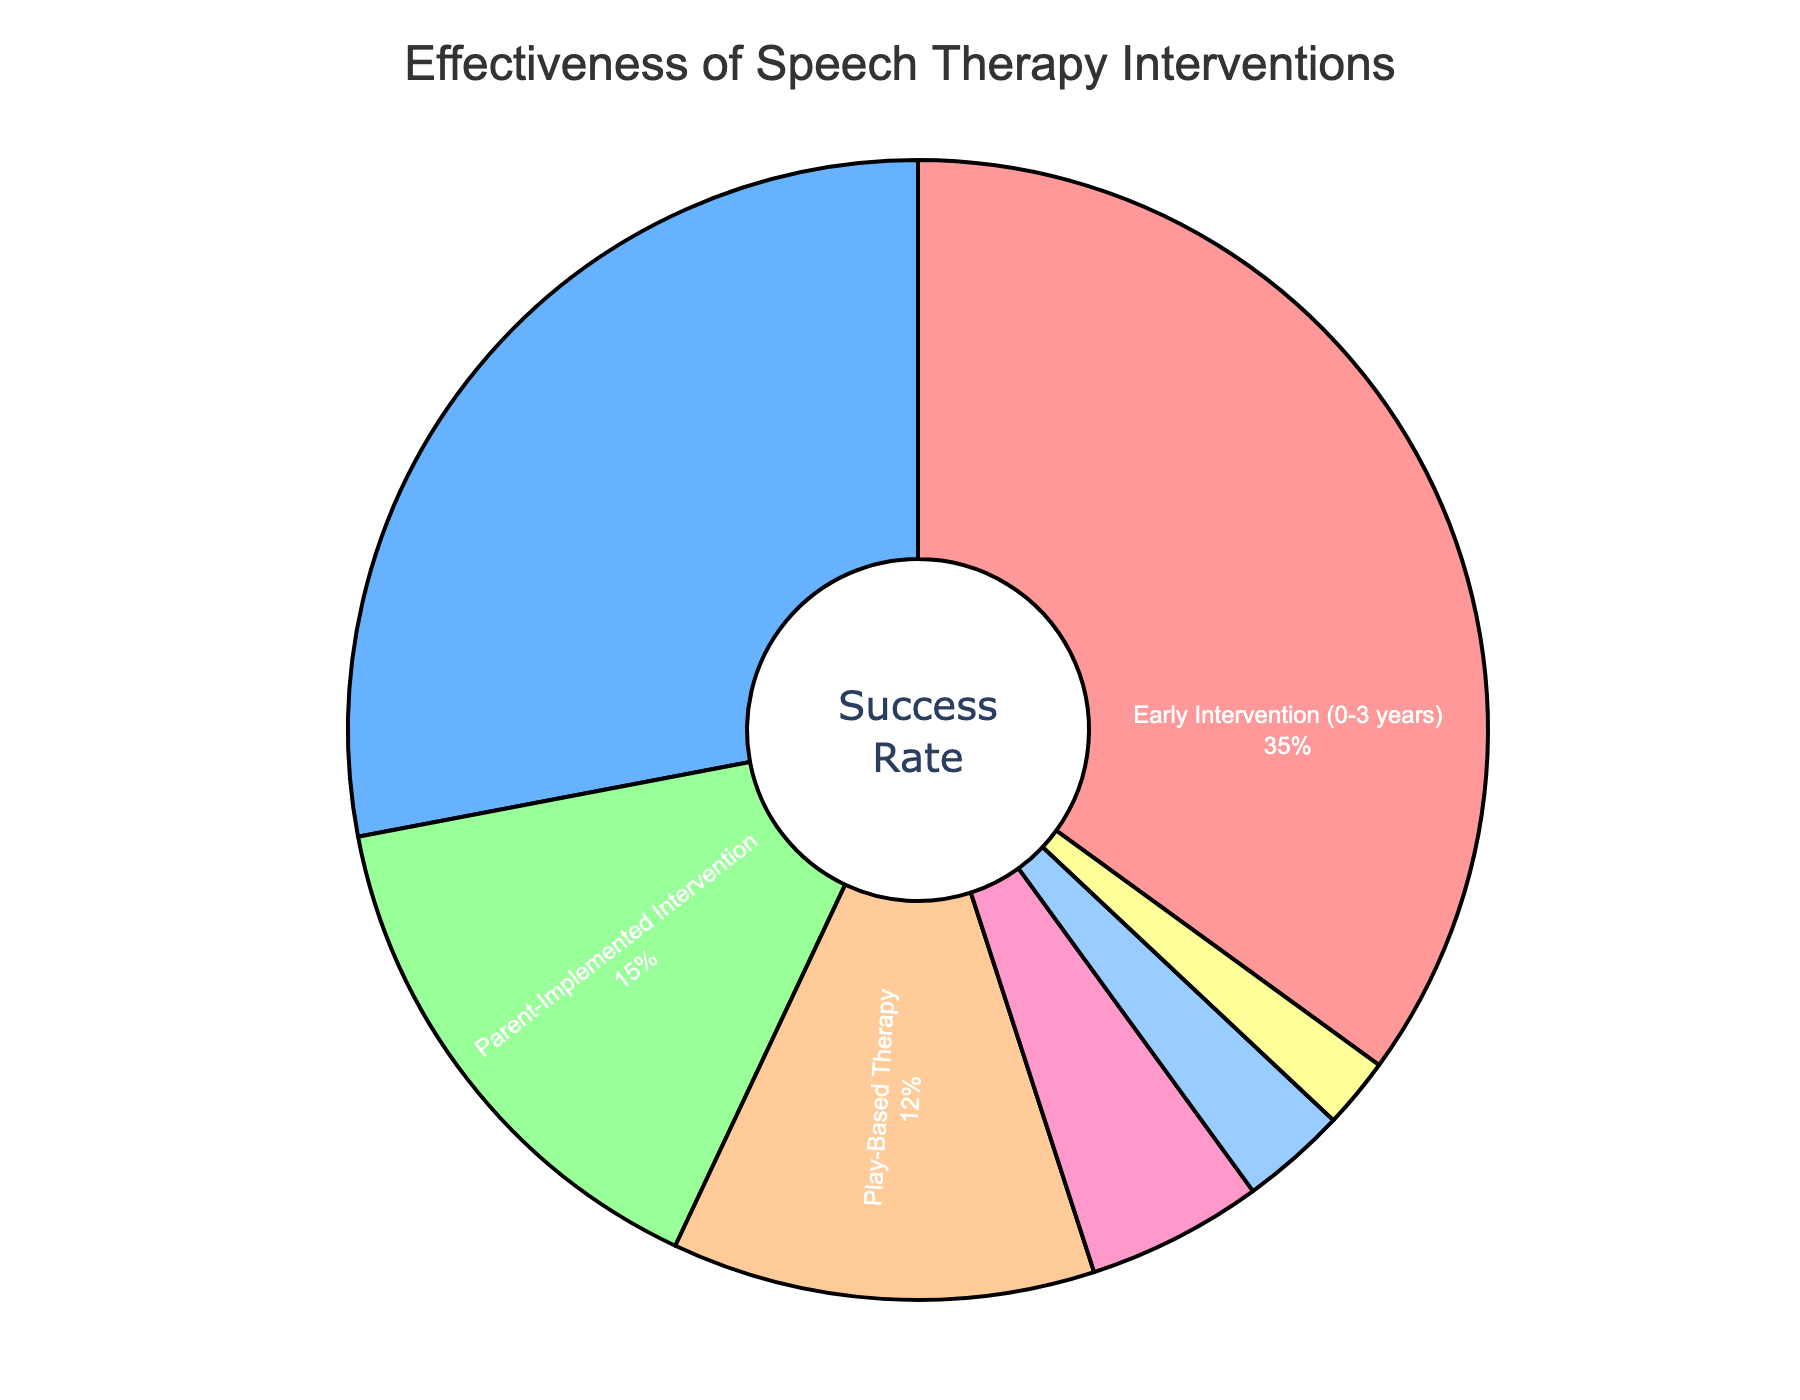What percentage of success is attributed to Early Intervention? The pie chart shows the percentage attributed to each intervention. By locating "Early Intervention (0-3 years)" on the chart, you see it represents 35%.
Answer: 35% How does the success rate of Speech-Language Pathology Sessions compare to Parent-Implemented Intervention? The pie chart reveals the success rates of each intervention. Speech-Language Pathology Sessions have a 28% success rate, while Parent-Implemented Intervention has a 15% success rate. Therefore, Speech-Language Pathology Sessions are more effective.
Answer: Speech-Language Pathology Sessions are more effective Which intervention has the least success rate and what is it? The pie chart shows success rates as percentages. The intervention with the smallest segment corresponding to the lowest rate is Music Therapy, at 2%.
Answer: Music Therapy at 2% What percentage of success is attributed to interventions other than Early Intervention and Speech-Language Pathology Sessions? Add the success rates of the remaining interventions: Parent-Implemented Intervention (15%), Play-Based Therapy (12%), Augmentative and Alternative Communication (AAC) (5%), Group Therapy Sessions (3%), Music Therapy (2%). Sum: 15 + 12 + 5 + 3 + 2 = 37%
Answer: 37% Which therapy's success rate is depicted in purple color in the pie chart? Identify the segment colored purple, according to typical color schemes used in the code where AAC (5%) would use the fifth color (purple). By checking other identified colored segments, you find that Augmentative and Alternative Communication (AAC) stands out.
Answer: Augmentative and Alternative Communication (AAC) What is the sum of the success rates for Parent-Implemented Intervention and Play-Based Therapy? The pie chart represents the success rates for both interventions. Add the rates: Parent-Implemented Intervention (15%) + Play-Based Therapy (12%) = 27%.
Answer: 27% Is the sum of the success rates for Group Therapy Sessions and Music Therapy greater or less than 10%? Group Therapy Sessions have a 3% success rate, and Music Therapy has 2%. Adding both, 3% + 2% = 5%, which is less than 10%.
Answer: Less than 10% What is the visual relationship between the teal-colored section and the yellow-colored section in the pie chart? Identify the segments by their colors for Play-Based Therapy (teal, 12%) and Early Intervention (yellow, 35%). The teal section is shorter than the yellow section.
Answer: Teal section shorter How does the visual length of the Speech-Language Pathology Sessions segment compare to the Augmentative and Alternative Communication (AAC) segment? Locate Speech-Language Pathology (blue, 28%) and AAC (purple, 5%) segments. Visually, the Speech-Language Pathology segment is significantly larger than the AAC segment.
Answer: Speech-Language Pathology is larger 